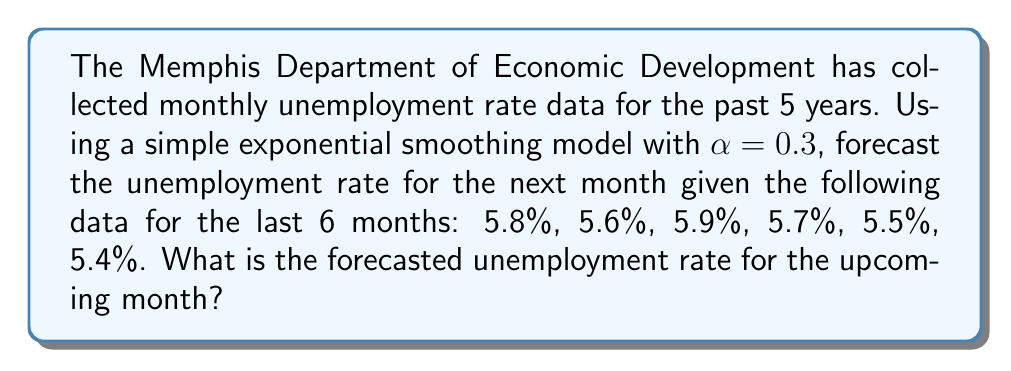Can you solve this math problem? To solve this problem, we'll use the simple exponential smoothing model, which is a time series forecasting technique. The formula for this model is:

$$F_{t+1} = \alpha Y_t + (1-\alpha)F_t$$

Where:
$F_{t+1}$ is the forecast for the next period
$\alpha$ is the smoothing factor (given as 0.3)
$Y_t$ is the actual value at time t
$F_t$ is the forecast for the current period

Let's calculate step by step:

1) First, we need an initial forecast. We'll use the first actual value: 5.8%

2) Now, let's calculate each forecast:

   For month 2: $F_2 = 0.3(5.8) + 0.7(5.8) = 5.8$
   For month 3: $F_3 = 0.3(5.6) + 0.7(5.8) = 5.74$
   For month 4: $F_4 = 0.3(5.9) + 0.7(5.74) = 5.788$
   For month 5: $F_5 = 0.3(5.7) + 0.7(5.788) = 5.7616$
   For month 6: $F_6 = 0.3(5.5) + 0.7(5.7616) = 5.68312$

3) Finally, for the forecast of the next month:

   $F_7 = 0.3(5.4) + 0.7(5.68312) = 5.598184$

4) Rounding to two decimal places: 5.60%
Answer: 5.60% 